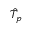Convert formula to latex. <formula><loc_0><loc_0><loc_500><loc_500>\hat { T } _ { p }</formula> 